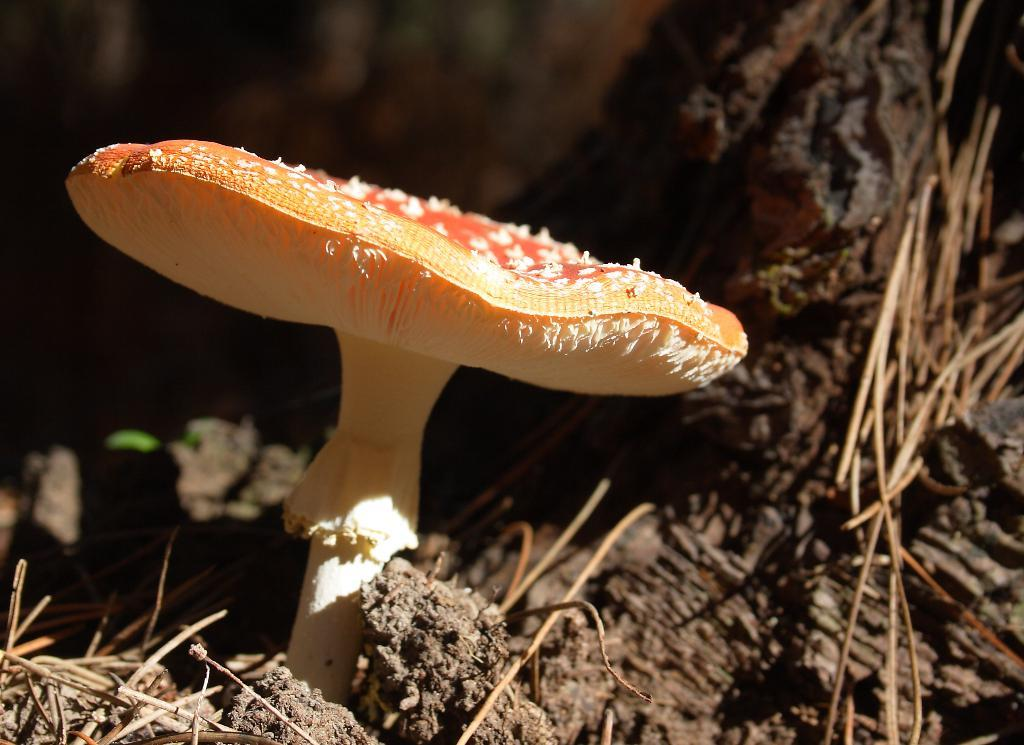What type of plant can be seen in the image? There is a mushroom in the image. What other natural elements are present in the image? There is a tree and dry grass on the surface in the image. How many kittens are sitting on the calendar in the image? There is no calendar or kittens present in the image. 